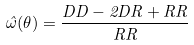Convert formula to latex. <formula><loc_0><loc_0><loc_500><loc_500>\hat { \omega } ( \theta ) = \frac { D D - 2 D R + R R } { R R }</formula> 